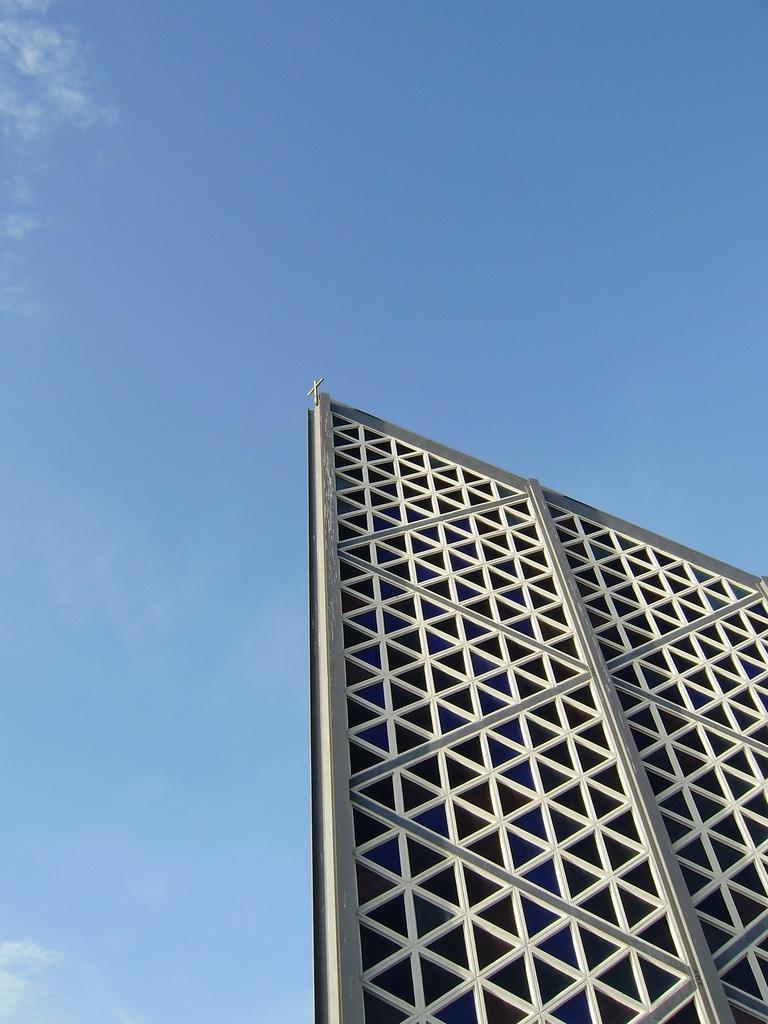What is the main subject in the image? There is a large advertising board in the image. What can be seen in the background of the image? The sky is visible in the background of the image. How many potatoes are stacked on top of the advertising board in the image? There are no potatoes present in the image; it features a large advertising board and the sky in the background. 